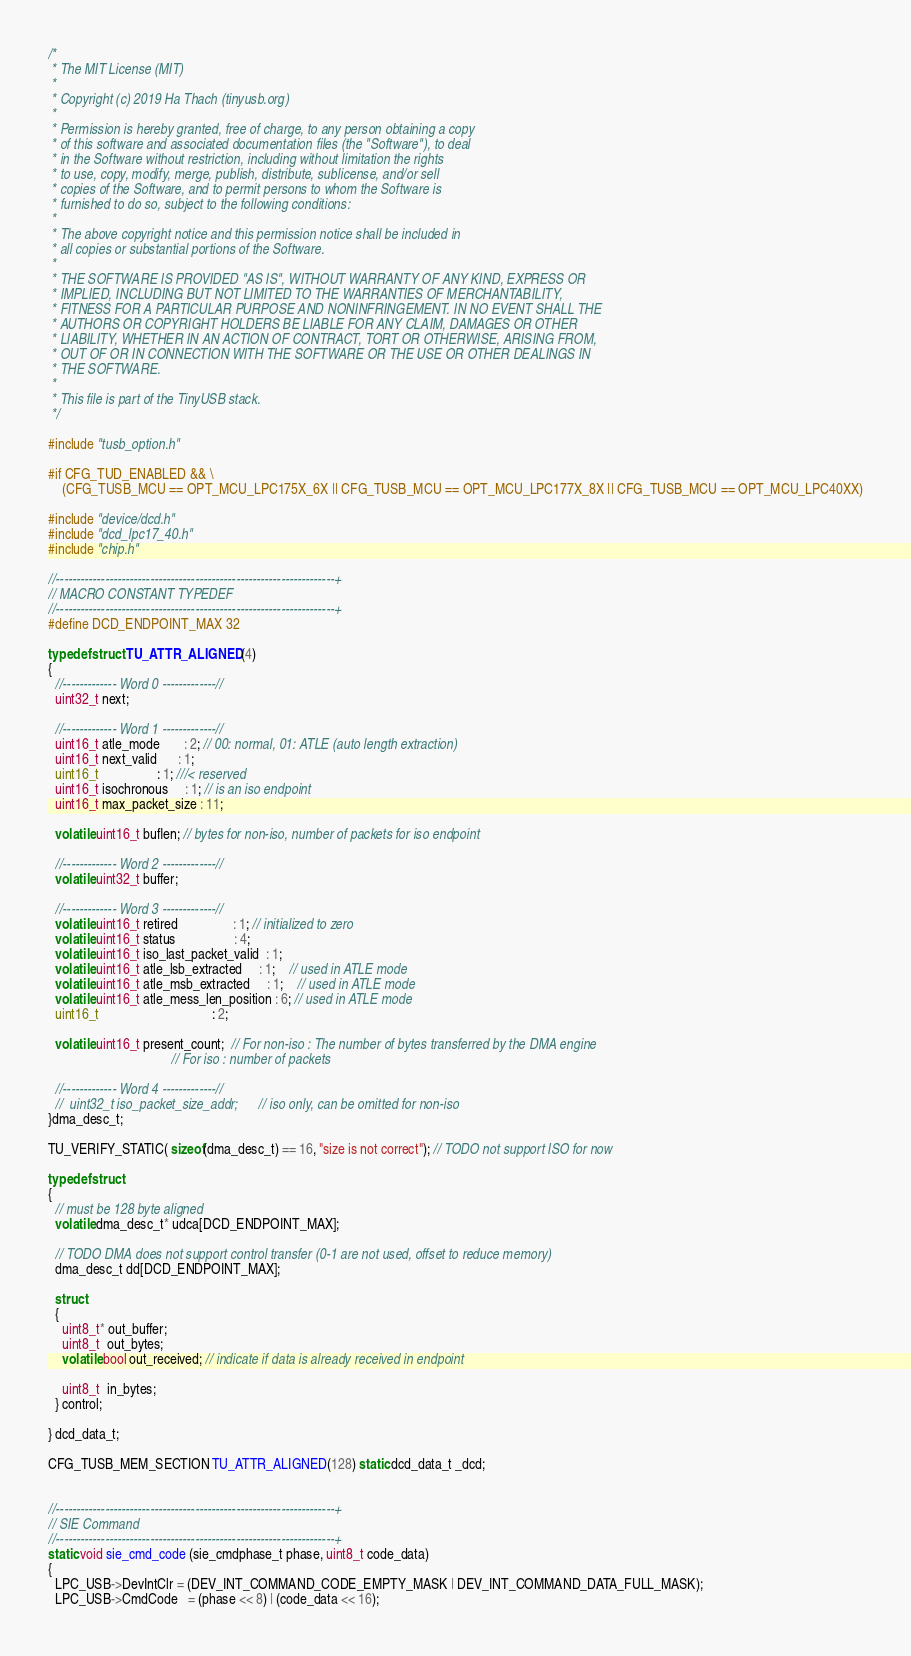<code> <loc_0><loc_0><loc_500><loc_500><_C_>/* 
 * The MIT License (MIT)
 *
 * Copyright (c) 2019 Ha Thach (tinyusb.org)
 *
 * Permission is hereby granted, free of charge, to any person obtaining a copy
 * of this software and associated documentation files (the "Software"), to deal
 * in the Software without restriction, including without limitation the rights
 * to use, copy, modify, merge, publish, distribute, sublicense, and/or sell
 * copies of the Software, and to permit persons to whom the Software is
 * furnished to do so, subject to the following conditions:
 *
 * The above copyright notice and this permission notice shall be included in
 * all copies or substantial portions of the Software.
 *
 * THE SOFTWARE IS PROVIDED "AS IS", WITHOUT WARRANTY OF ANY KIND, EXPRESS OR
 * IMPLIED, INCLUDING BUT NOT LIMITED TO THE WARRANTIES OF MERCHANTABILITY,
 * FITNESS FOR A PARTICULAR PURPOSE AND NONINFRINGEMENT. IN NO EVENT SHALL THE
 * AUTHORS OR COPYRIGHT HOLDERS BE LIABLE FOR ANY CLAIM, DAMAGES OR OTHER
 * LIABILITY, WHETHER IN AN ACTION OF CONTRACT, TORT OR OTHERWISE, ARISING FROM,
 * OUT OF OR IN CONNECTION WITH THE SOFTWARE OR THE USE OR OTHER DEALINGS IN
 * THE SOFTWARE.
 *
 * This file is part of the TinyUSB stack.
 */

#include "tusb_option.h"

#if CFG_TUD_ENABLED && \
    (CFG_TUSB_MCU == OPT_MCU_LPC175X_6X || CFG_TUSB_MCU == OPT_MCU_LPC177X_8X || CFG_TUSB_MCU == OPT_MCU_LPC40XX)

#include "device/dcd.h"
#include "dcd_lpc17_40.h"
#include "chip.h"

//--------------------------------------------------------------------+
// MACRO CONSTANT TYPEDEF
//--------------------------------------------------------------------+
#define DCD_ENDPOINT_MAX 32

typedef struct TU_ATTR_ALIGNED(4)
{
  //------------- Word 0 -------------//
  uint32_t next;

  //------------- Word 1 -------------//
  uint16_t atle_mode       : 2; // 00: normal, 01: ATLE (auto length extraction)
  uint16_t next_valid      : 1;
  uint16_t                 : 1; ///< reserved
  uint16_t isochronous     : 1; // is an iso endpoint
  uint16_t max_packet_size : 11;

  volatile uint16_t buflen; // bytes for non-iso, number of packets for iso endpoint

  //------------- Word 2 -------------//
  volatile uint32_t buffer;

  //------------- Word 3 -------------//
  volatile uint16_t retired                : 1; // initialized to zero
  volatile uint16_t status                 : 4;
  volatile uint16_t iso_last_packet_valid  : 1;
  volatile uint16_t atle_lsb_extracted     : 1;	// used in ATLE mode
  volatile uint16_t atle_msb_extracted     : 1;	// used in ATLE mode
  volatile uint16_t atle_mess_len_position : 6; // used in ATLE mode
  uint16_t                                 : 2;

  volatile uint16_t present_count;  // For non-iso : The number of bytes transferred by the DMA engine
                                    // For iso : number of packets

  //------------- Word 4 -------------//
  //	uint32_t iso_packet_size_addr;		// iso only, can be omitted for non-iso
}dma_desc_t;

TU_VERIFY_STATIC( sizeof(dma_desc_t) == 16, "size is not correct"); // TODO not support ISO for now

typedef struct
{
  // must be 128 byte aligned
  volatile dma_desc_t* udca[DCD_ENDPOINT_MAX];

  // TODO DMA does not support control transfer (0-1 are not used, offset to reduce memory)
  dma_desc_t dd[DCD_ENDPOINT_MAX];

  struct
  {
    uint8_t* out_buffer;
    uint8_t  out_bytes;
    volatile bool out_received; // indicate if data is already received in endpoint

    uint8_t  in_bytes;
  } control;

} dcd_data_t;

CFG_TUSB_MEM_SECTION TU_ATTR_ALIGNED(128) static dcd_data_t _dcd;


//--------------------------------------------------------------------+
// SIE Command
//--------------------------------------------------------------------+
static void sie_cmd_code (sie_cmdphase_t phase, uint8_t code_data)
{
  LPC_USB->DevIntClr = (DEV_INT_COMMAND_CODE_EMPTY_MASK | DEV_INT_COMMAND_DATA_FULL_MASK);
  LPC_USB->CmdCode   = (phase << 8) | (code_data << 16);
</code> 